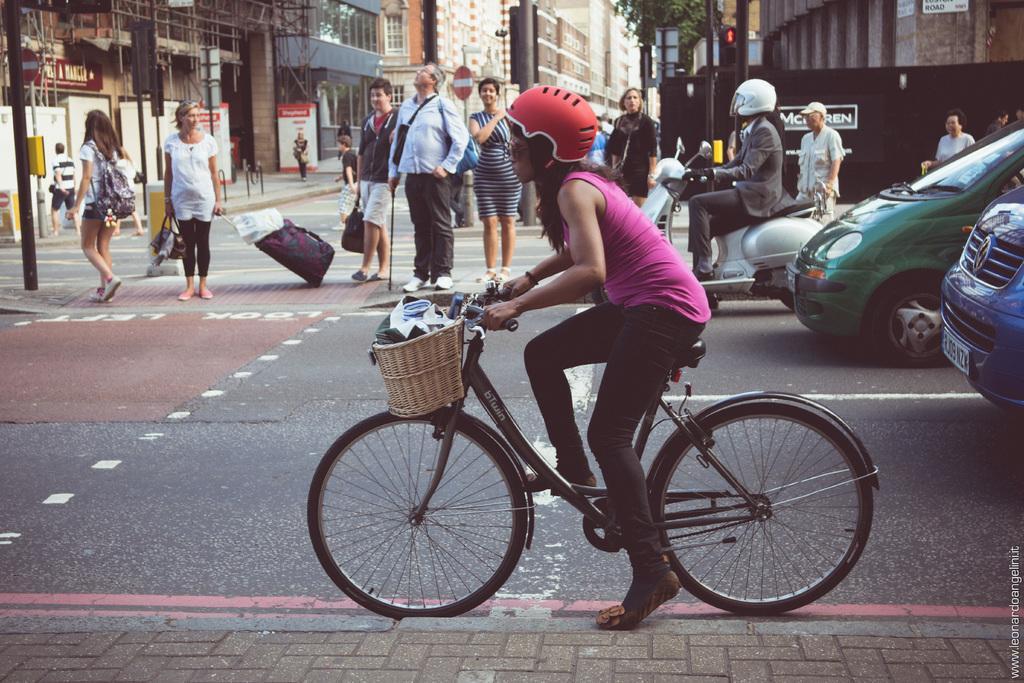Describe this image in one or two sentences. The image is taken on the street, there are some people who are walking on the path a girl is riding a cycle, beside her there is a footpath, in the background there are some other vehicles. 